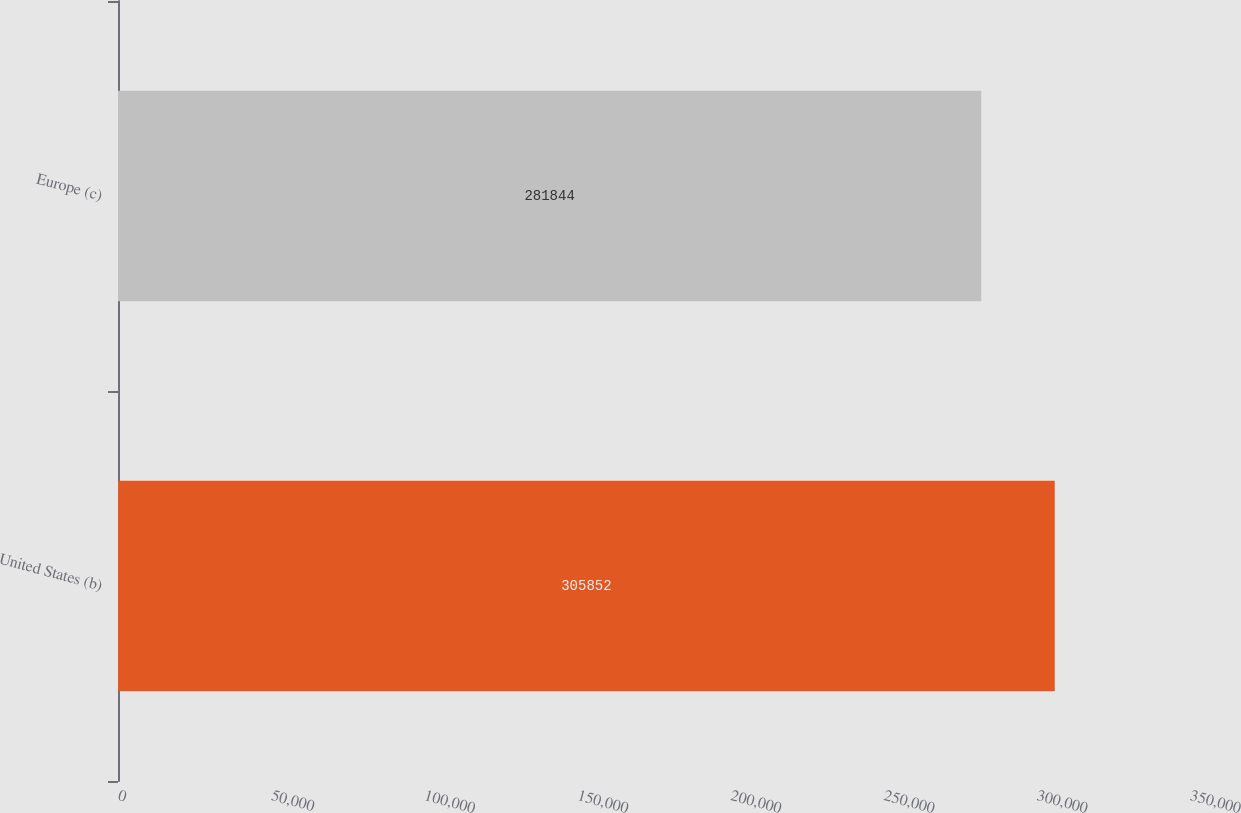Convert chart. <chart><loc_0><loc_0><loc_500><loc_500><bar_chart><fcel>United States (b)<fcel>Europe (c)<nl><fcel>305852<fcel>281844<nl></chart> 